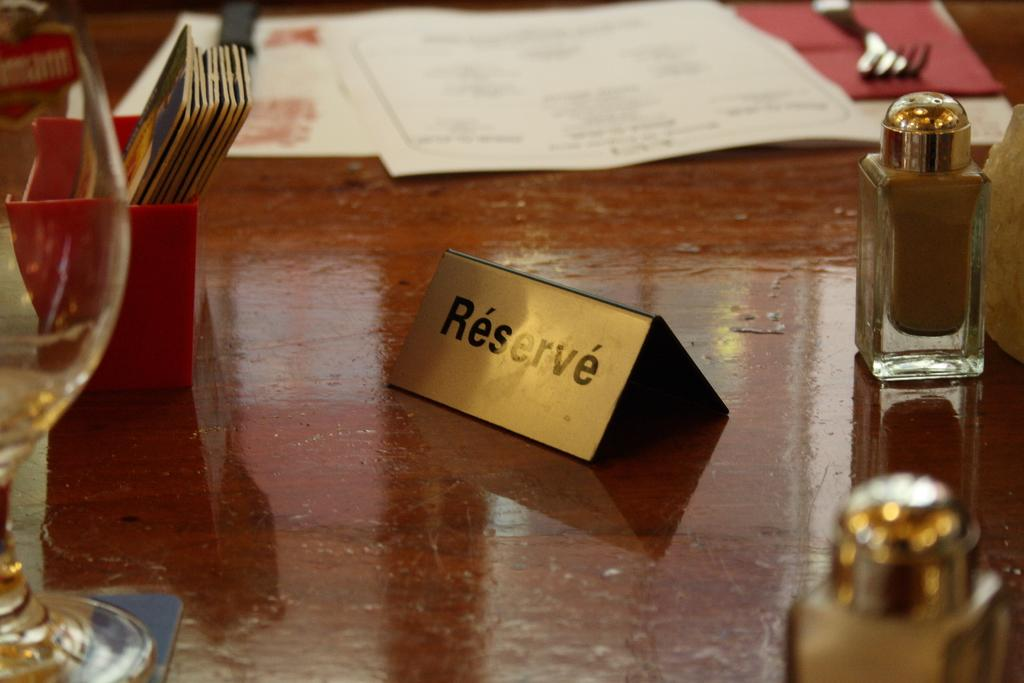<image>
Present a compact description of the photo's key features. A small gold sign indicates that a table is not available because it has been reserved. 